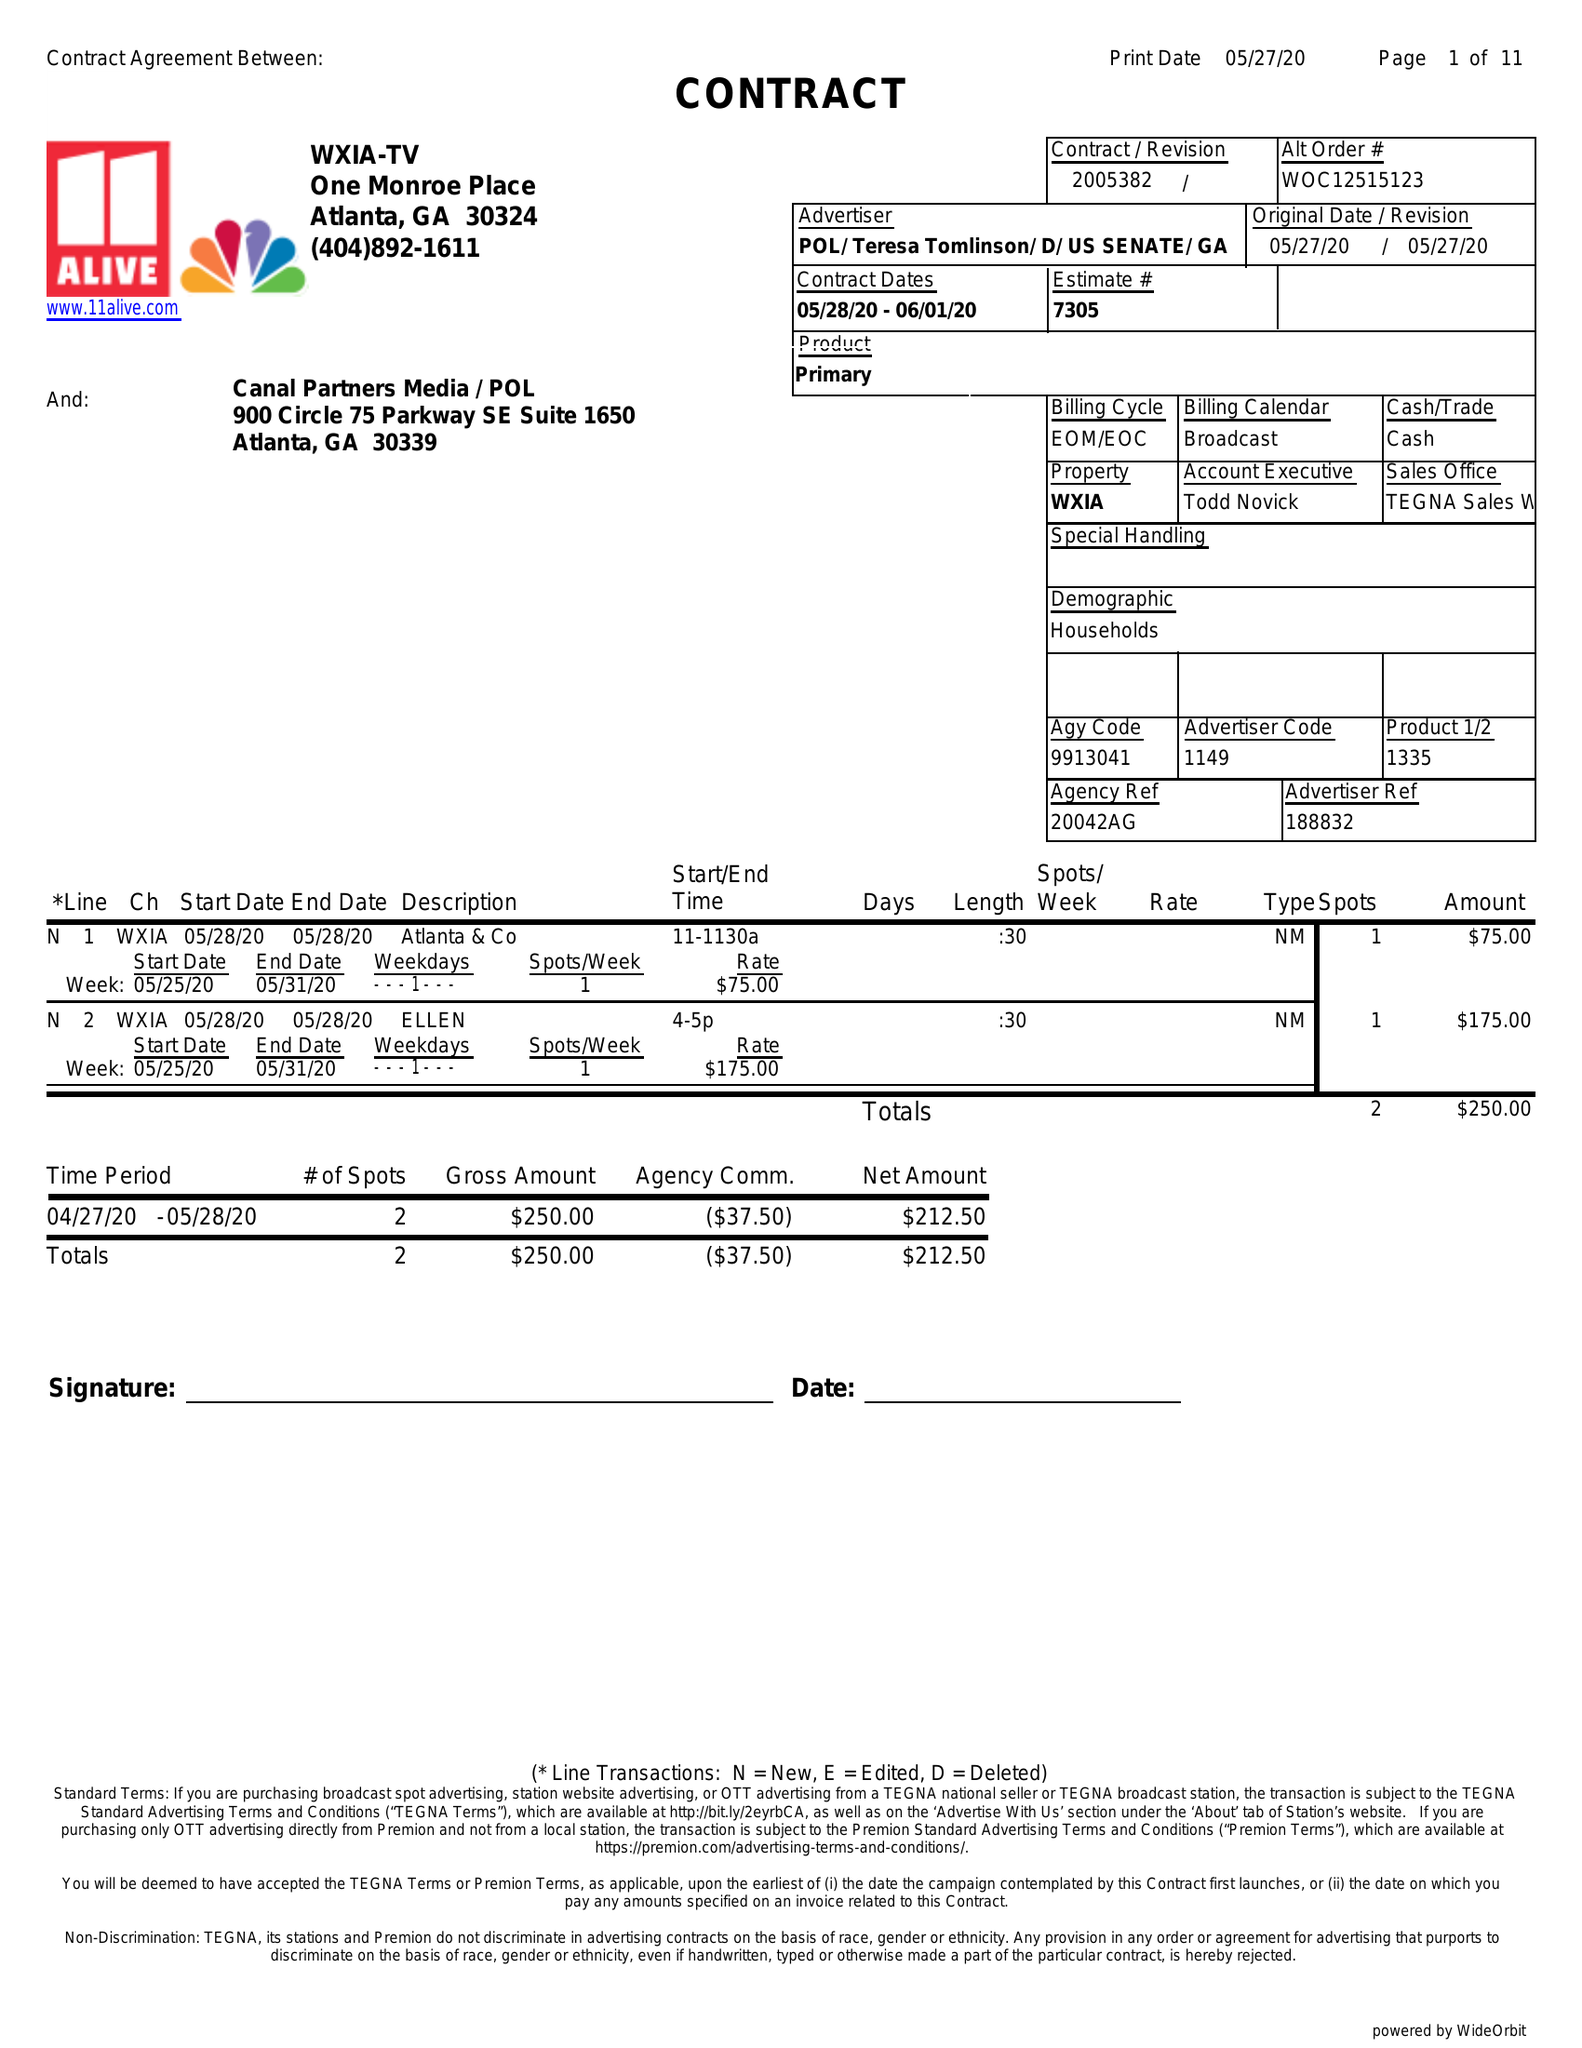What is the value for the gross_amount?
Answer the question using a single word or phrase. 250.00 